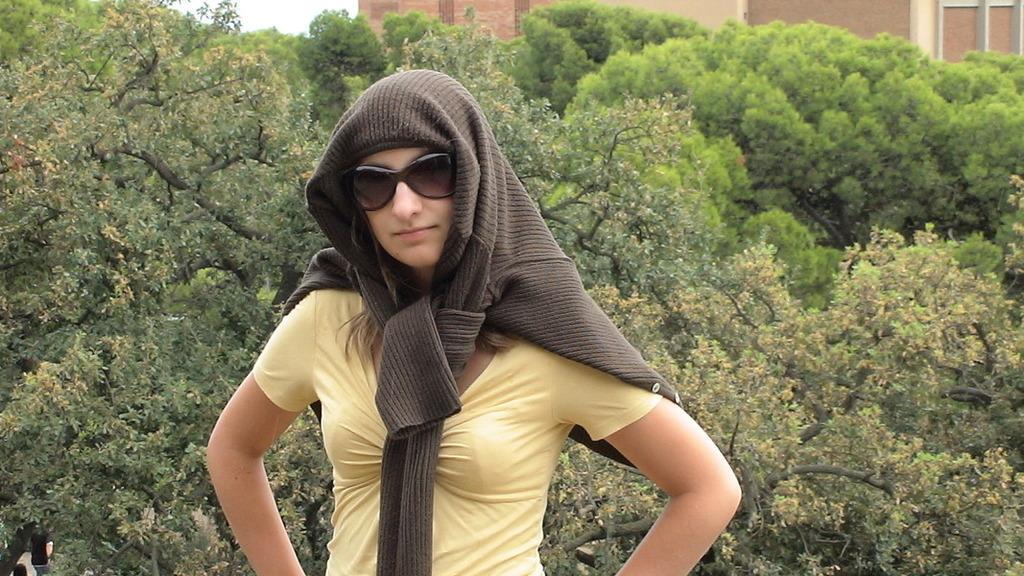Could you give a brief overview of what you see in this image? In this image we can see a person with goggles and in the background there are few trees, buildings and the sky. 